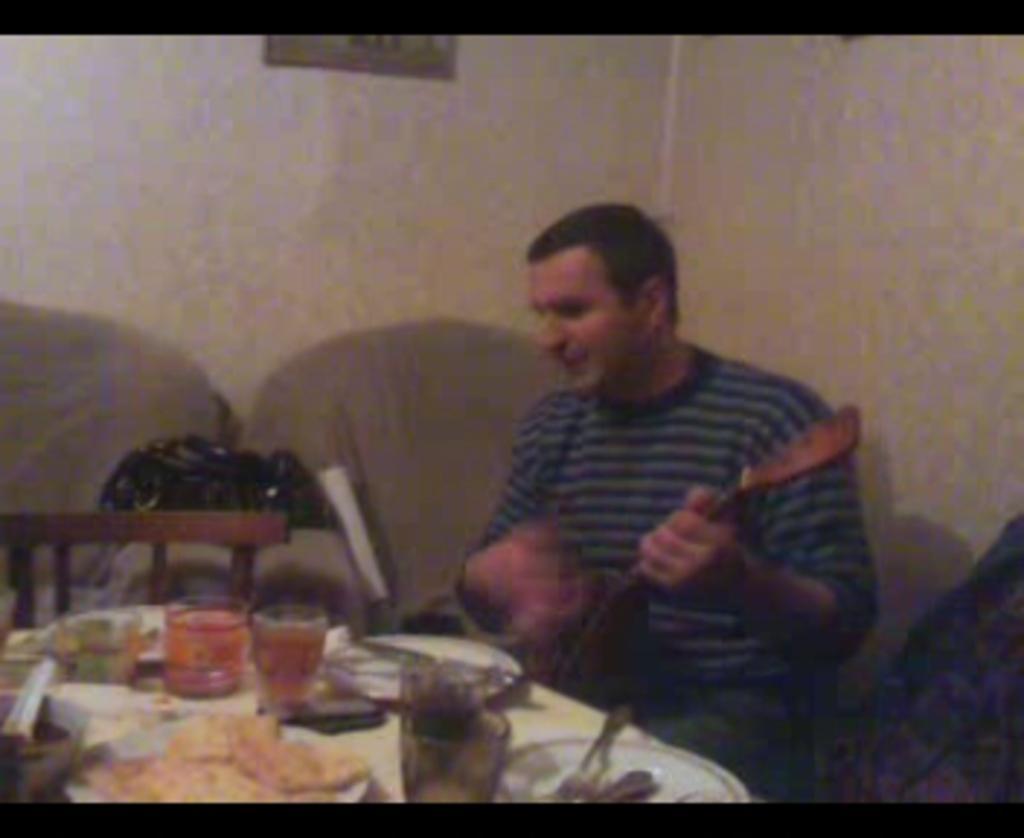In one or two sentences, can you explain what this image depicts? This image consists of a table, chairs. One person is sitting in a chair. He is playing guitar. on the table there are plates, glasses, forks, spoons. 